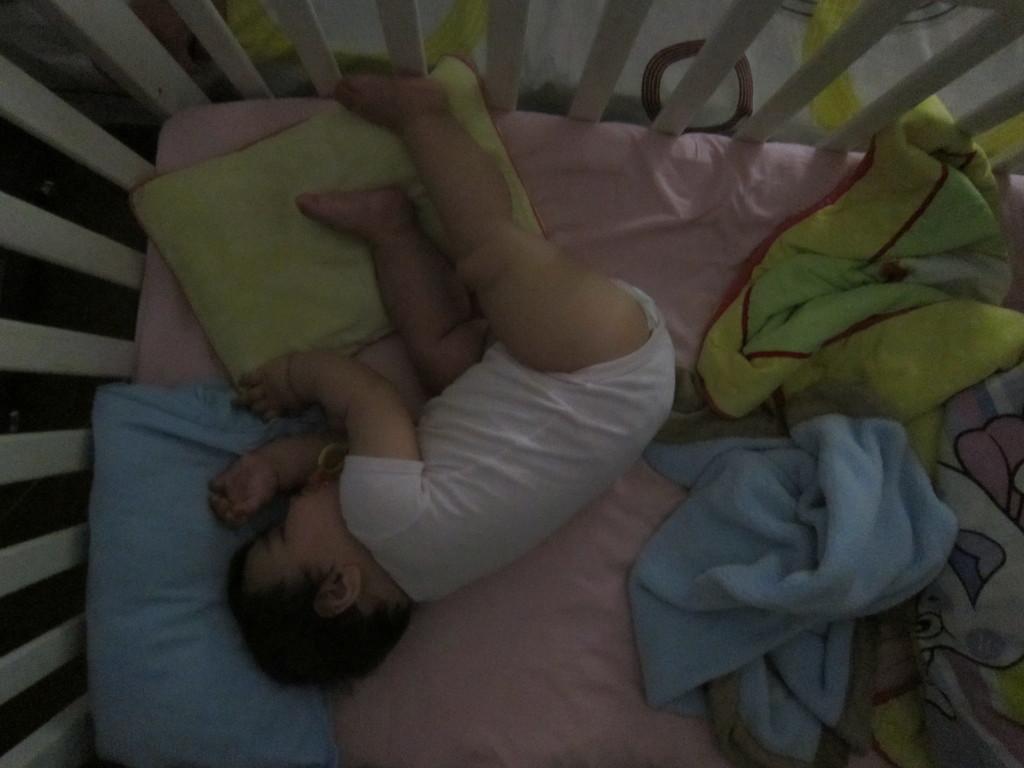Can you describe this image briefly? In this image I can see a baby sleeping on the bed. I can see blue and green color pillows, at right I can see blue and yellow color blankets. 